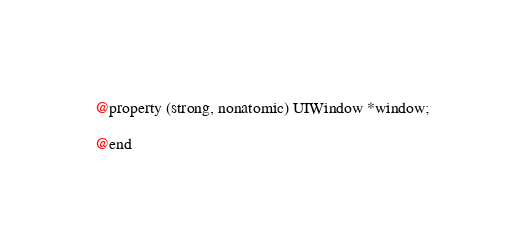Convert code to text. <code><loc_0><loc_0><loc_500><loc_500><_C_>@property (strong, nonatomic) UIWindow *window;

@end
</code> 